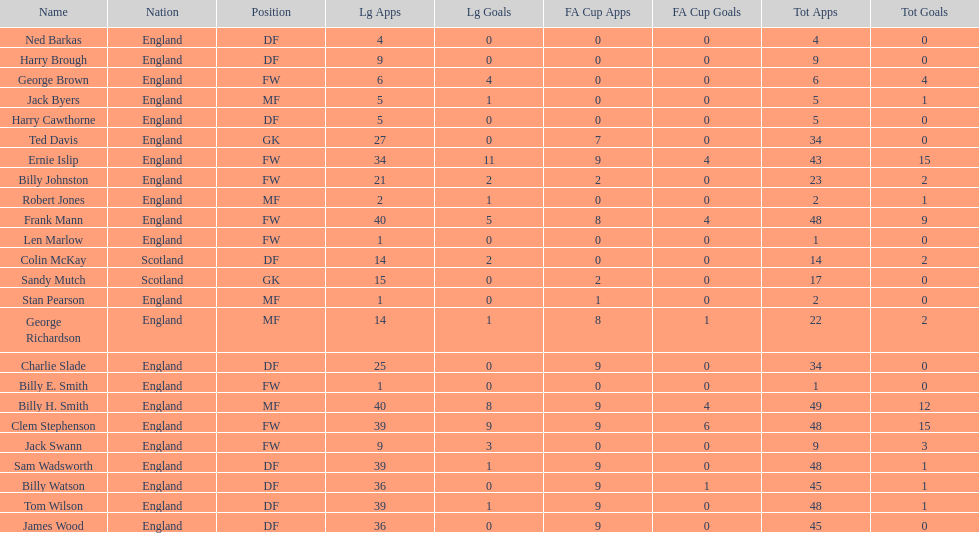The least number of total appearances 1. 